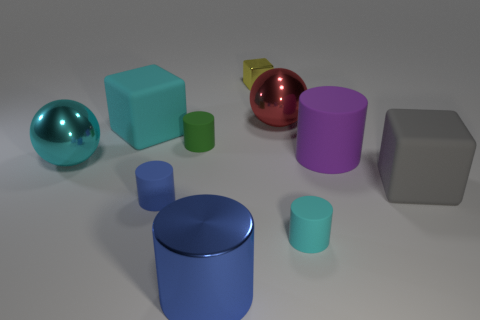The other block that is the same size as the gray block is what color? cyan 